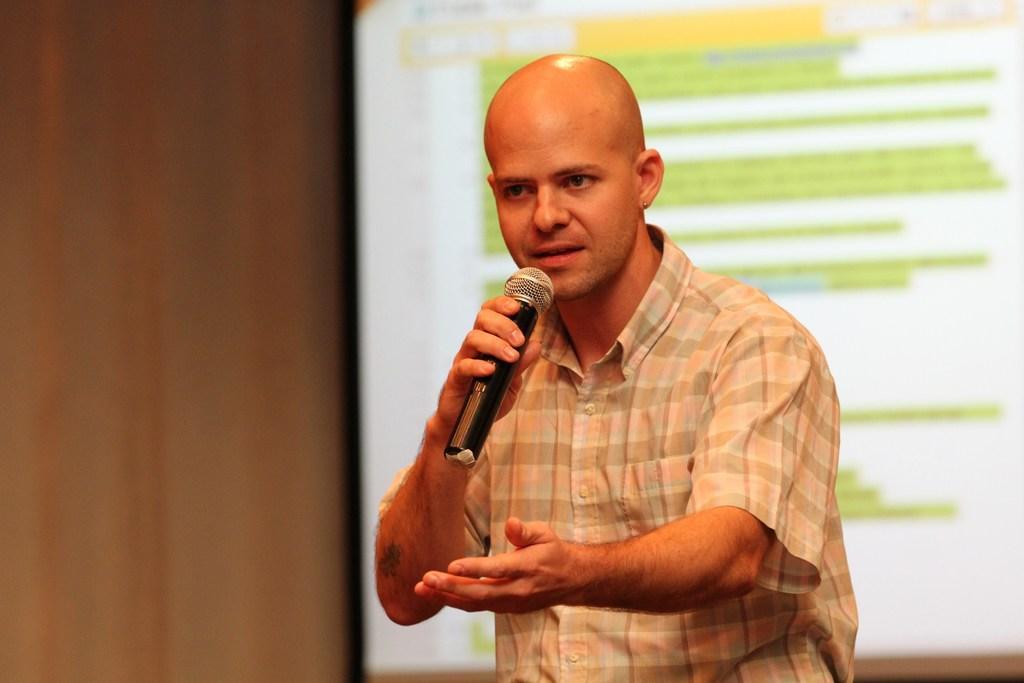Can you describe this image briefly? In this image there is a person holding mike is wearing a shirt. At the background there is a screen having some text. 